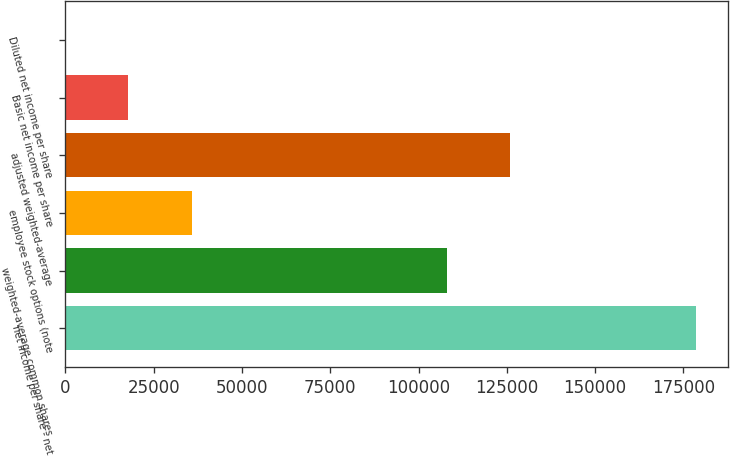<chart> <loc_0><loc_0><loc_500><loc_500><bar_chart><fcel>net income per share - net<fcel>weighted-average common shares<fcel>employee stock options (note<fcel>adjusted weighted-average<fcel>Basic net income per share<fcel>Diluted net income per share<nl><fcel>178634<fcel>108011<fcel>35728.1<fcel>125874<fcel>17864.9<fcel>1.64<nl></chart> 